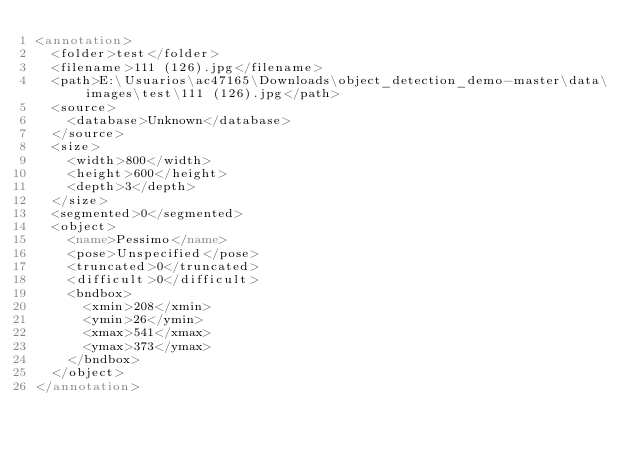<code> <loc_0><loc_0><loc_500><loc_500><_XML_><annotation>
	<folder>test</folder>
	<filename>111 (126).jpg</filename>
	<path>E:\Usuarios\ac47165\Downloads\object_detection_demo-master\data\images\test\111 (126).jpg</path>
	<source>
		<database>Unknown</database>
	</source>
	<size>
		<width>800</width>
		<height>600</height>
		<depth>3</depth>
	</size>
	<segmented>0</segmented>
	<object>
		<name>Pessimo</name>
		<pose>Unspecified</pose>
		<truncated>0</truncated>
		<difficult>0</difficult>
		<bndbox>
			<xmin>208</xmin>
			<ymin>26</ymin>
			<xmax>541</xmax>
			<ymax>373</ymax>
		</bndbox>
	</object>
</annotation>
</code> 